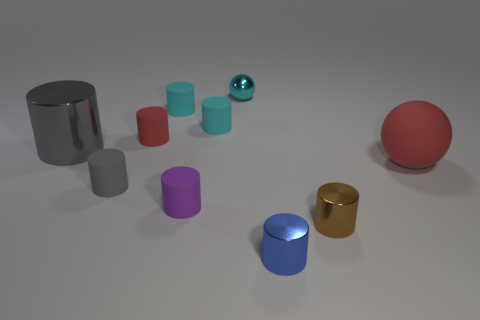How big is the red matte object in front of the metal object on the left side of the tiny cyan shiny thing?
Your answer should be compact. Large. Are there fewer big spheres in front of the purple rubber cylinder than small gray rubber things?
Your response must be concise. Yes. The gray metal object has what size?
Keep it short and to the point. Large. How many rubber cylinders are the same color as the big shiny thing?
Ensure brevity in your answer.  1. There is a sphere that is right of the small metallic cylinder in front of the tiny brown thing; are there any small cylinders that are in front of it?
Provide a short and direct response. Yes. There is a brown thing that is the same size as the blue metal thing; what shape is it?
Offer a very short reply. Cylinder. What number of big objects are either brown cylinders or blue metallic things?
Offer a very short reply. 0. What color is the ball that is made of the same material as the big cylinder?
Ensure brevity in your answer.  Cyan. There is a large thing that is on the right side of the gray shiny object; does it have the same shape as the red matte object that is behind the big metal thing?
Provide a short and direct response. No. How many rubber objects are either tiny blocks or tiny spheres?
Your answer should be very brief. 0. 